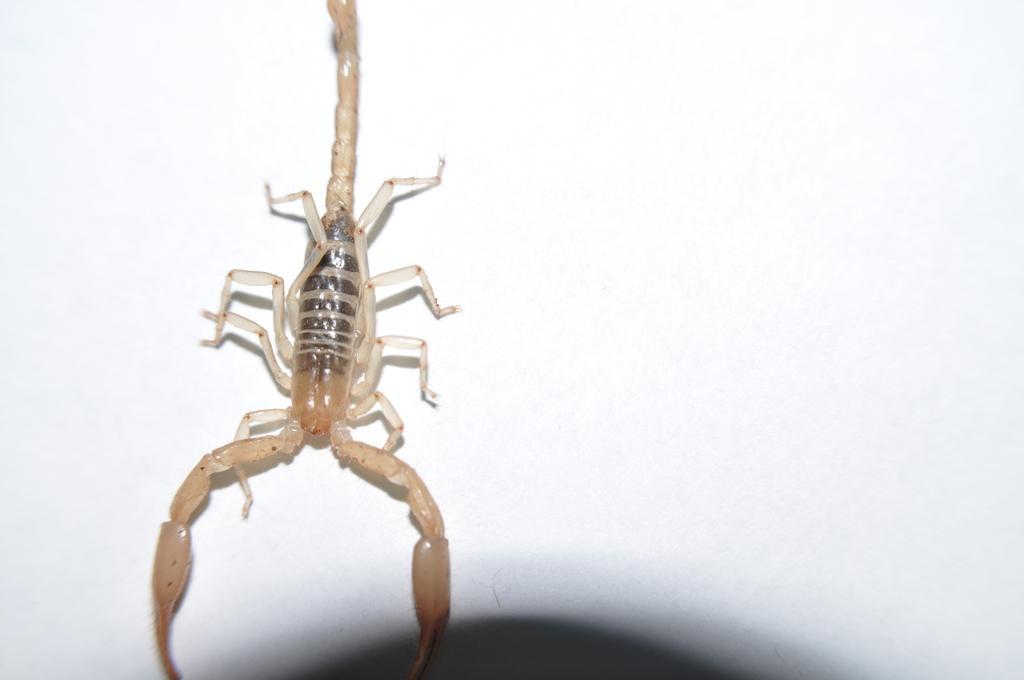Can you describe this image briefly? In the center of the image we can see one scorpion, which is in black and cream color. 